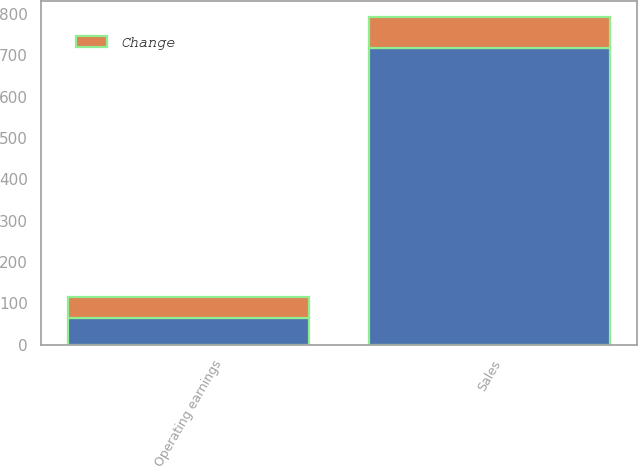Convert chart. <chart><loc_0><loc_0><loc_500><loc_500><stacked_bar_chart><ecel><fcel>Sales<fcel>Operating earnings<nl><fcel>nan<fcel>718<fcel>64<nl><fcel>Change<fcel>74<fcel>51<nl></chart> 